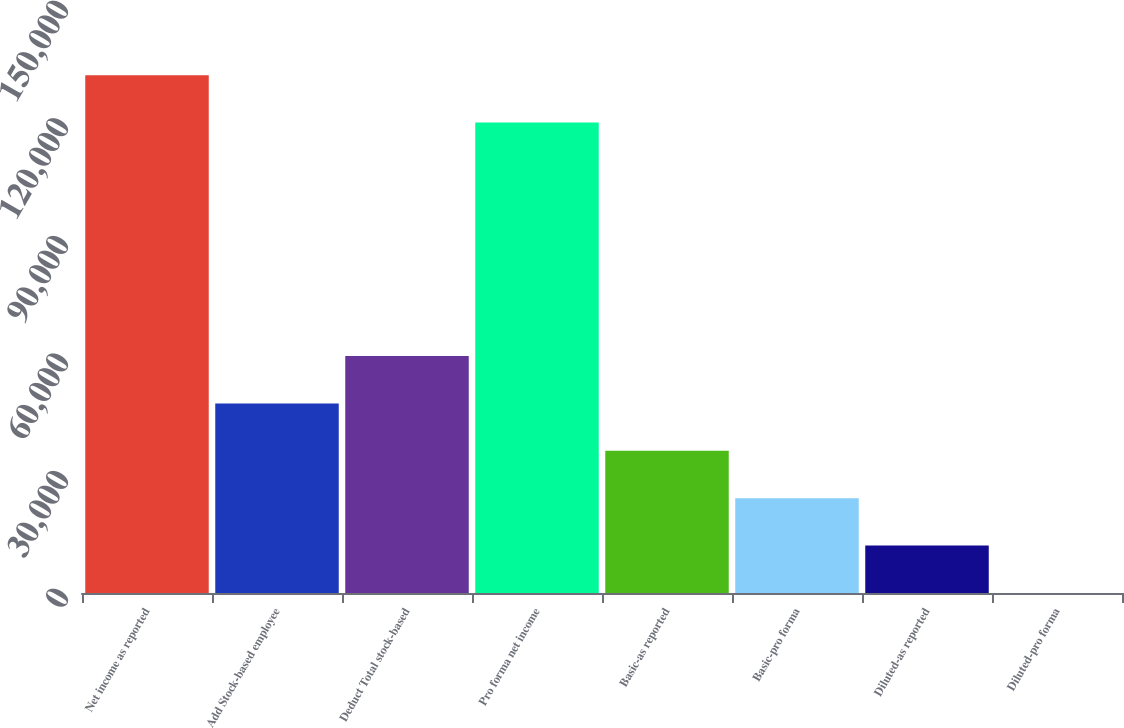Convert chart to OTSL. <chart><loc_0><loc_0><loc_500><loc_500><bar_chart><fcel>Net income as reported<fcel>Add Stock-based employee<fcel>Deduct Total stock-based<fcel>Pro forma net income<fcel>Basic-as reported<fcel>Basic-pro forma<fcel>Diluted-as reported<fcel>Diluted-pro forma<nl><fcel>132087<fcel>48360.9<fcel>60450.7<fcel>119997<fcel>36271<fcel>24181.1<fcel>12091.3<fcel>1.42<nl></chart> 